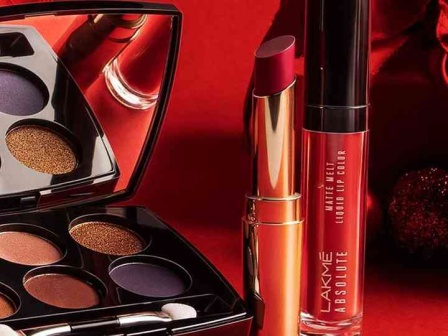What are the key elements in this picture? The image presents a vibrant display of three makeup products from the Lakme Absolute collection, arranged on a striking red background. The eyeshadow palette, which is open, is the centerpiece of the arrangement. It offers six distinct shades, half of them shimmering in gold tones and the other half in various shades of purple. 

To the right of the palette, there's a lipstick in a metallic gold color, its cap off to reveal the lustrous shade. On the left, a liquid lip color in a deep, rich red hue completes the trio. The word "LAK" is visible, hinting at the brand name 'Lakme'. The precise placement of these items creates a balanced composition, with each product having its own space while contributing to the overall aesthetic of the image. 